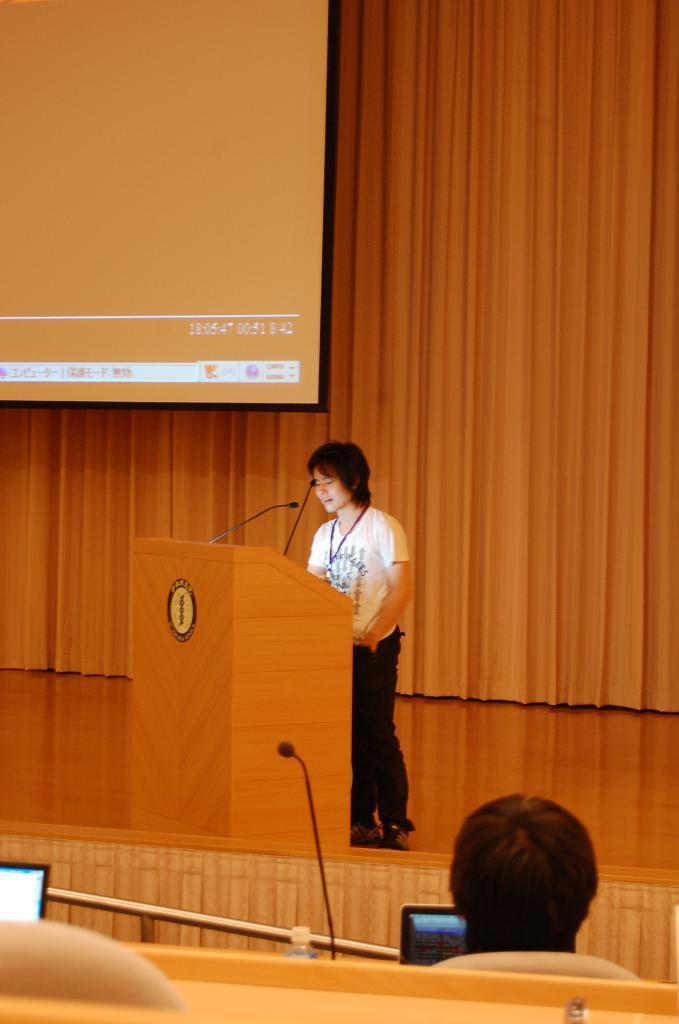Can you describe this image briefly? This picture seems to be clicked inside the hall. In the foreground we can see a person seems to be sitting on the chair and we can see a microphone and the electronic devices and the metal rod. In the center we can see a person wearing t-shirt and standing behind the wooden podium and we can see the microphones seems to be attached to the wooden podium and we can see a logo with the text on the podium. In the background we can see the curtain and the screen. 